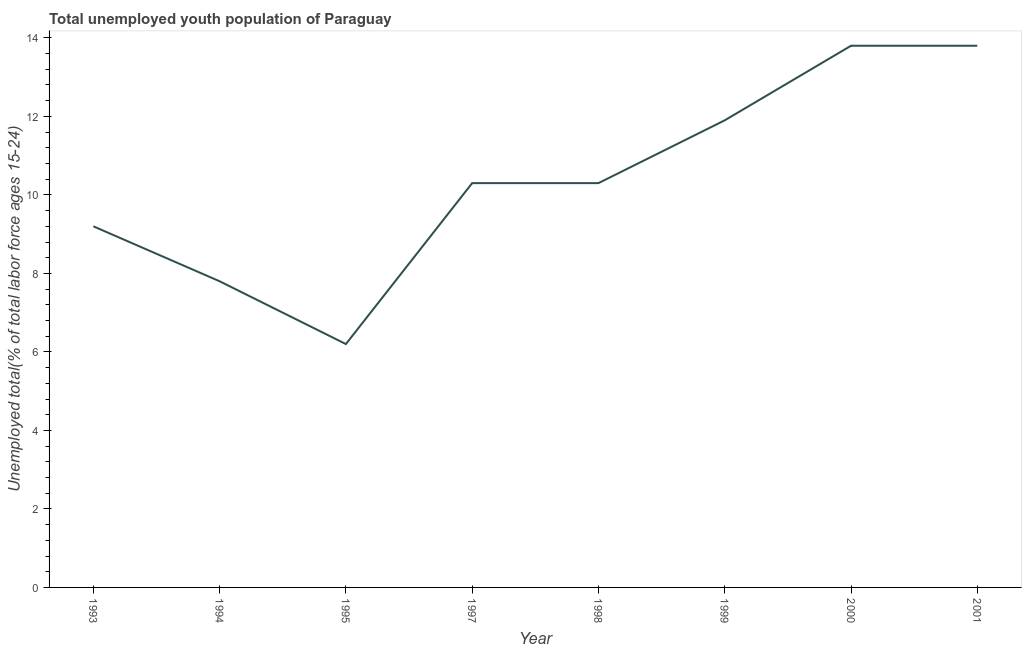What is the unemployed youth in 2001?
Offer a very short reply. 13.8. Across all years, what is the maximum unemployed youth?
Ensure brevity in your answer.  13.8. Across all years, what is the minimum unemployed youth?
Ensure brevity in your answer.  6.2. In which year was the unemployed youth maximum?
Offer a very short reply. 2000. In which year was the unemployed youth minimum?
Provide a succinct answer. 1995. What is the sum of the unemployed youth?
Offer a very short reply. 83.3. What is the difference between the unemployed youth in 1993 and 1999?
Your answer should be very brief. -2.7. What is the average unemployed youth per year?
Your answer should be compact. 10.41. What is the median unemployed youth?
Provide a short and direct response. 10.3. In how many years, is the unemployed youth greater than 0.8 %?
Your answer should be very brief. 8. What is the ratio of the unemployed youth in 1993 to that in 1997?
Offer a terse response. 0.89. Is the unemployed youth in 1998 less than that in 1999?
Keep it short and to the point. Yes. Is the difference between the unemployed youth in 1994 and 1998 greater than the difference between any two years?
Your response must be concise. No. What is the difference between the highest and the second highest unemployed youth?
Ensure brevity in your answer.  0. What is the difference between the highest and the lowest unemployed youth?
Your response must be concise. 7.6. In how many years, is the unemployed youth greater than the average unemployed youth taken over all years?
Provide a short and direct response. 3. How many years are there in the graph?
Your answer should be compact. 8. Does the graph contain any zero values?
Your answer should be very brief. No. Does the graph contain grids?
Keep it short and to the point. No. What is the title of the graph?
Ensure brevity in your answer.  Total unemployed youth population of Paraguay. What is the label or title of the X-axis?
Your answer should be compact. Year. What is the label or title of the Y-axis?
Keep it short and to the point. Unemployed total(% of total labor force ages 15-24). What is the Unemployed total(% of total labor force ages 15-24) of 1993?
Your answer should be very brief. 9.2. What is the Unemployed total(% of total labor force ages 15-24) of 1994?
Your answer should be very brief. 7.8. What is the Unemployed total(% of total labor force ages 15-24) of 1995?
Make the answer very short. 6.2. What is the Unemployed total(% of total labor force ages 15-24) of 1997?
Offer a terse response. 10.3. What is the Unemployed total(% of total labor force ages 15-24) of 1998?
Your answer should be compact. 10.3. What is the Unemployed total(% of total labor force ages 15-24) in 1999?
Offer a very short reply. 11.9. What is the Unemployed total(% of total labor force ages 15-24) in 2000?
Make the answer very short. 13.8. What is the Unemployed total(% of total labor force ages 15-24) in 2001?
Your response must be concise. 13.8. What is the difference between the Unemployed total(% of total labor force ages 15-24) in 1993 and 1994?
Keep it short and to the point. 1.4. What is the difference between the Unemployed total(% of total labor force ages 15-24) in 1993 and 2001?
Your response must be concise. -4.6. What is the difference between the Unemployed total(% of total labor force ages 15-24) in 1994 and 1995?
Offer a terse response. 1.6. What is the difference between the Unemployed total(% of total labor force ages 15-24) in 1994 and 1997?
Offer a terse response. -2.5. What is the difference between the Unemployed total(% of total labor force ages 15-24) in 1994 and 2000?
Offer a terse response. -6. What is the difference between the Unemployed total(% of total labor force ages 15-24) in 1995 and 1999?
Your answer should be compact. -5.7. What is the difference between the Unemployed total(% of total labor force ages 15-24) in 1995 and 2001?
Keep it short and to the point. -7.6. What is the difference between the Unemployed total(% of total labor force ages 15-24) in 1997 and 2000?
Provide a succinct answer. -3.5. What is the difference between the Unemployed total(% of total labor force ages 15-24) in 1997 and 2001?
Offer a very short reply. -3.5. What is the difference between the Unemployed total(% of total labor force ages 15-24) in 1998 and 1999?
Your answer should be very brief. -1.6. What is the difference between the Unemployed total(% of total labor force ages 15-24) in 1998 and 2000?
Your answer should be compact. -3.5. What is the difference between the Unemployed total(% of total labor force ages 15-24) in 2000 and 2001?
Provide a succinct answer. 0. What is the ratio of the Unemployed total(% of total labor force ages 15-24) in 1993 to that in 1994?
Keep it short and to the point. 1.18. What is the ratio of the Unemployed total(% of total labor force ages 15-24) in 1993 to that in 1995?
Your response must be concise. 1.48. What is the ratio of the Unemployed total(% of total labor force ages 15-24) in 1993 to that in 1997?
Make the answer very short. 0.89. What is the ratio of the Unemployed total(% of total labor force ages 15-24) in 1993 to that in 1998?
Offer a very short reply. 0.89. What is the ratio of the Unemployed total(% of total labor force ages 15-24) in 1993 to that in 1999?
Offer a terse response. 0.77. What is the ratio of the Unemployed total(% of total labor force ages 15-24) in 1993 to that in 2000?
Provide a succinct answer. 0.67. What is the ratio of the Unemployed total(% of total labor force ages 15-24) in 1993 to that in 2001?
Keep it short and to the point. 0.67. What is the ratio of the Unemployed total(% of total labor force ages 15-24) in 1994 to that in 1995?
Provide a short and direct response. 1.26. What is the ratio of the Unemployed total(% of total labor force ages 15-24) in 1994 to that in 1997?
Give a very brief answer. 0.76. What is the ratio of the Unemployed total(% of total labor force ages 15-24) in 1994 to that in 1998?
Your answer should be very brief. 0.76. What is the ratio of the Unemployed total(% of total labor force ages 15-24) in 1994 to that in 1999?
Keep it short and to the point. 0.66. What is the ratio of the Unemployed total(% of total labor force ages 15-24) in 1994 to that in 2000?
Keep it short and to the point. 0.56. What is the ratio of the Unemployed total(% of total labor force ages 15-24) in 1994 to that in 2001?
Provide a succinct answer. 0.56. What is the ratio of the Unemployed total(% of total labor force ages 15-24) in 1995 to that in 1997?
Make the answer very short. 0.6. What is the ratio of the Unemployed total(% of total labor force ages 15-24) in 1995 to that in 1998?
Give a very brief answer. 0.6. What is the ratio of the Unemployed total(% of total labor force ages 15-24) in 1995 to that in 1999?
Give a very brief answer. 0.52. What is the ratio of the Unemployed total(% of total labor force ages 15-24) in 1995 to that in 2000?
Your answer should be compact. 0.45. What is the ratio of the Unemployed total(% of total labor force ages 15-24) in 1995 to that in 2001?
Provide a short and direct response. 0.45. What is the ratio of the Unemployed total(% of total labor force ages 15-24) in 1997 to that in 1998?
Ensure brevity in your answer.  1. What is the ratio of the Unemployed total(% of total labor force ages 15-24) in 1997 to that in 1999?
Make the answer very short. 0.87. What is the ratio of the Unemployed total(% of total labor force ages 15-24) in 1997 to that in 2000?
Ensure brevity in your answer.  0.75. What is the ratio of the Unemployed total(% of total labor force ages 15-24) in 1997 to that in 2001?
Offer a terse response. 0.75. What is the ratio of the Unemployed total(% of total labor force ages 15-24) in 1998 to that in 1999?
Keep it short and to the point. 0.87. What is the ratio of the Unemployed total(% of total labor force ages 15-24) in 1998 to that in 2000?
Ensure brevity in your answer.  0.75. What is the ratio of the Unemployed total(% of total labor force ages 15-24) in 1998 to that in 2001?
Make the answer very short. 0.75. What is the ratio of the Unemployed total(% of total labor force ages 15-24) in 1999 to that in 2000?
Provide a short and direct response. 0.86. What is the ratio of the Unemployed total(% of total labor force ages 15-24) in 1999 to that in 2001?
Ensure brevity in your answer.  0.86. 